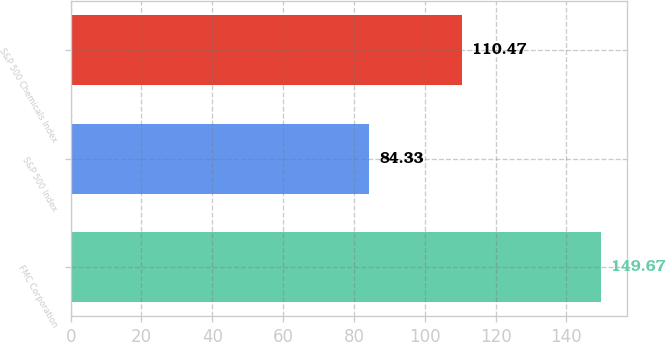Convert chart. <chart><loc_0><loc_0><loc_500><loc_500><bar_chart><fcel>FMC Corporation<fcel>S&P 500 Index<fcel>S&P 500 Chemicals Index<nl><fcel>149.67<fcel>84.33<fcel>110.47<nl></chart> 